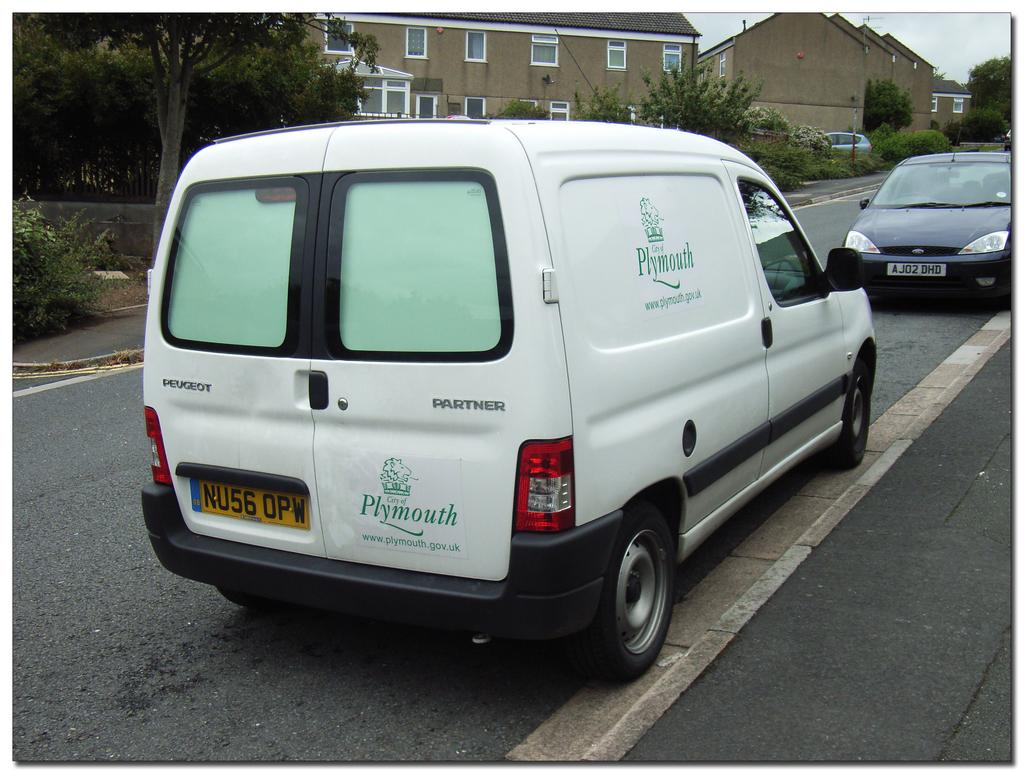<image>
Describe the image concisely. A white City of Plymouth van lists the website as www.plymouth.gov.uk. 